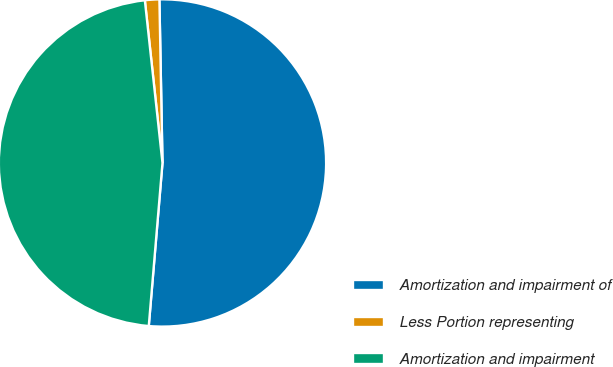Convert chart to OTSL. <chart><loc_0><loc_0><loc_500><loc_500><pie_chart><fcel>Amortization and impairment of<fcel>Less Portion representing<fcel>Amortization and impairment<nl><fcel>51.64%<fcel>1.42%<fcel>46.95%<nl></chart> 